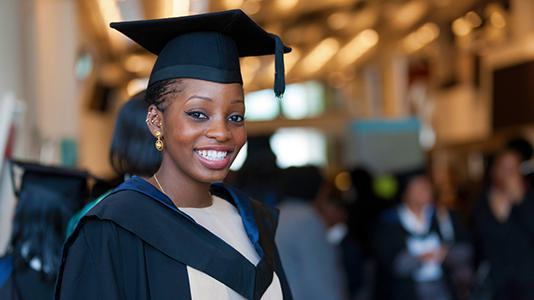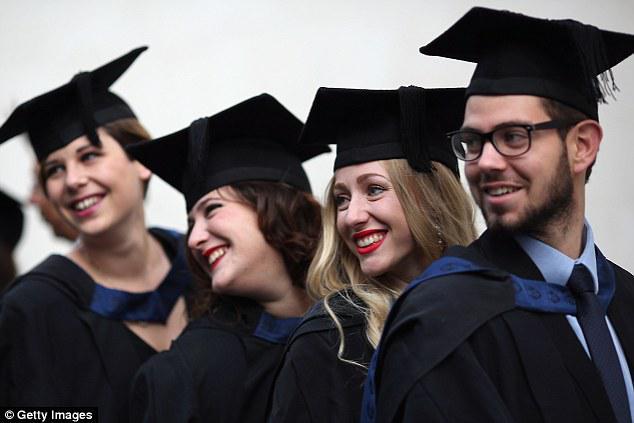The first image is the image on the left, the second image is the image on the right. For the images shown, is this caption "There are more people posing in their caps and gowns in the image on the right." true? Answer yes or no. Yes. The first image is the image on the left, the second image is the image on the right. Assess this claim about the two images: "All graduates wear dark caps and robes, and the left image shows a smiling black graduate alone in the foreground.". Correct or not? Answer yes or no. Yes. 